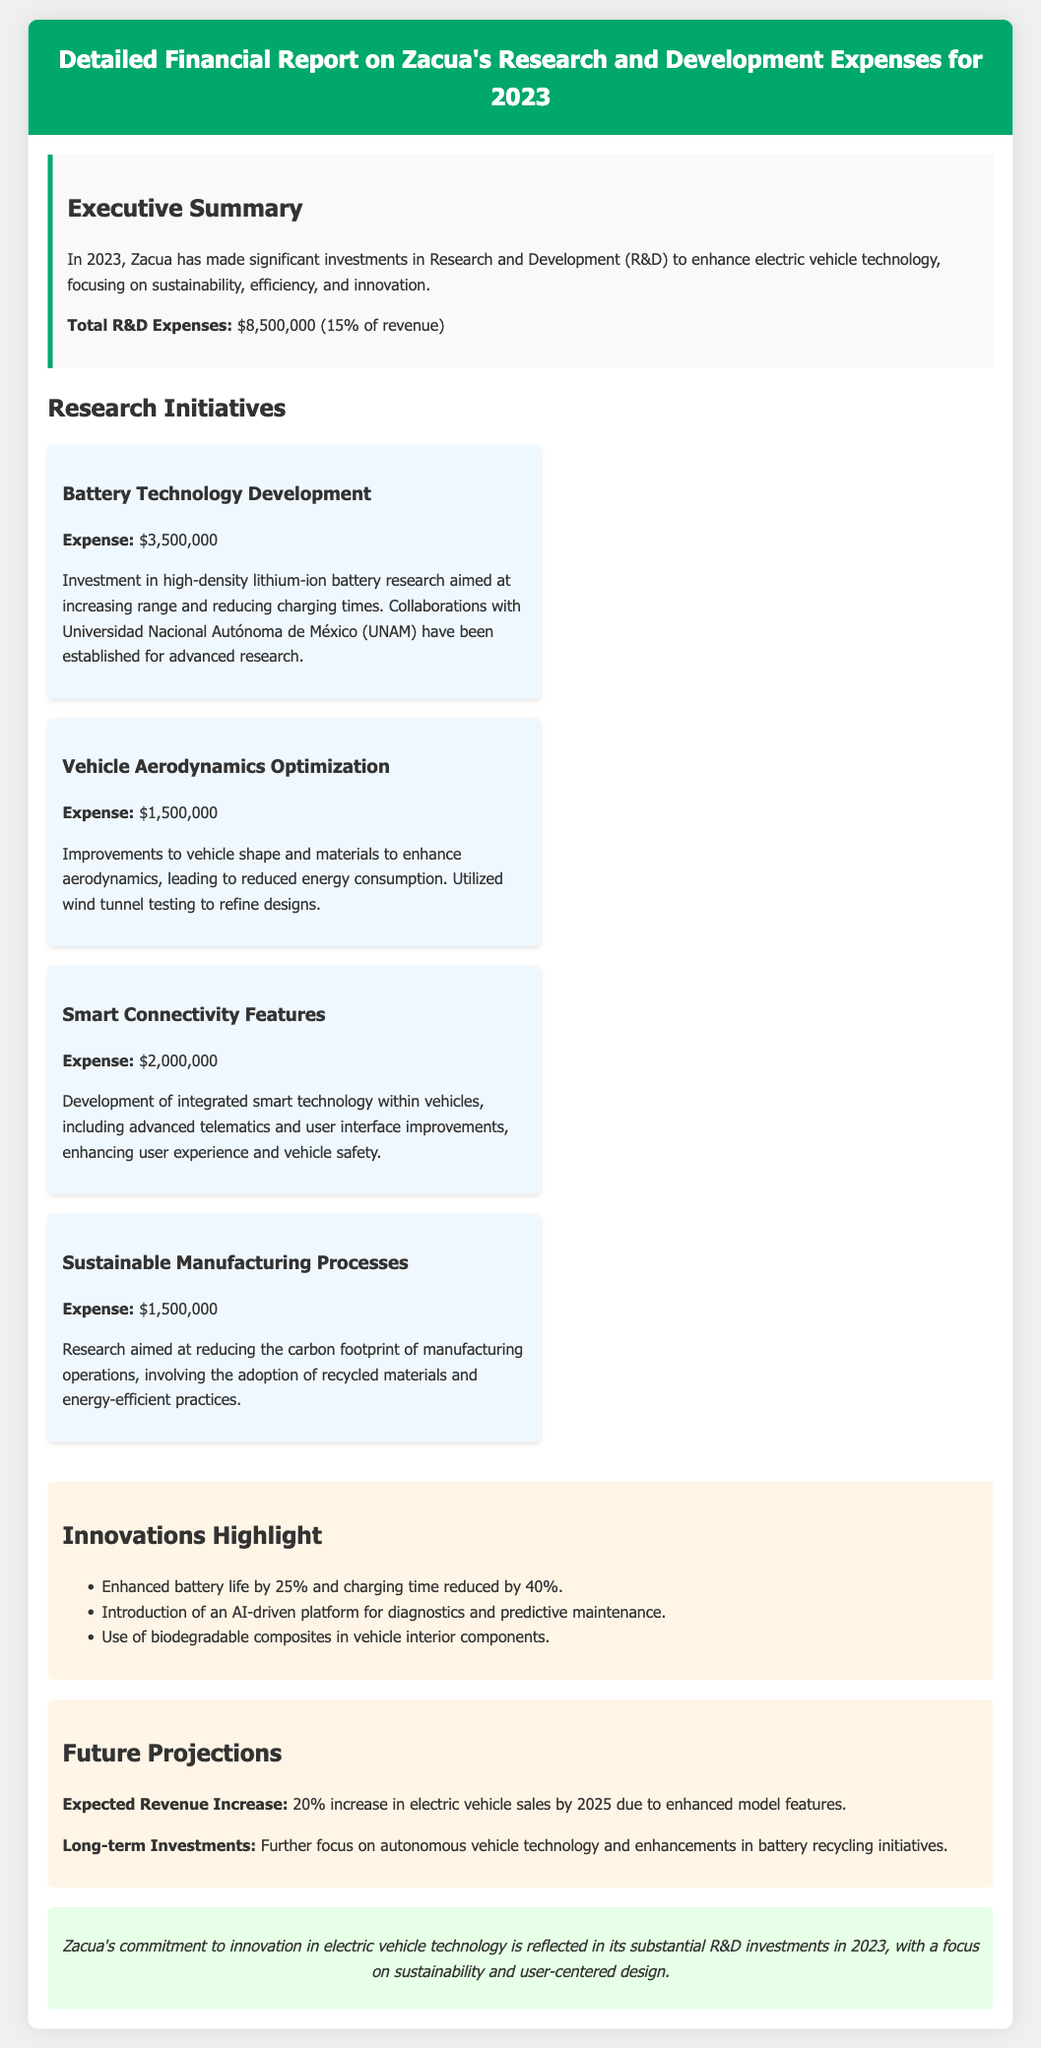What is the total R&D expense for 2023? The total R&D expense is stated in the executive summary of the document.
Answer: $8,500,000 How much was invested in battery technology development? The specific investment amount for battery technology development is listed under the research initiatives.
Answer: $3,500,000 What percentage of revenue does R&D expenses represent? The percentage of revenue attributed to R&D expenses is mentioned in the executive summary.
Answer: 15% Which university collaborated with Zacua for battery research? The document specifies the university involved in collaboration for advanced research.
Answer: Universidad Nacional Autónoma de México What improvement was reported in battery life? The document highlights specific innovations, including battery life improvements.
Answer: 25% What is the expected revenue increase by 2025? Future projections contain information on the anticipated increase in electric vehicle sales.
Answer: 20% How much was allocated for smart connectivity features? The amount allocated for smart connectivity features is listed under the initiatives section.
Answer: $2,000,000 What innovation is introduced for diagnostics and maintenance? The document mentions a specific platform aimed at improving vehicle diagnostics.
Answer: AI-driven platform What is the focus of long-term investments mentioned in the report? Long-term investments are discussed in the future projections section.
Answer: Autonomous vehicle technology 